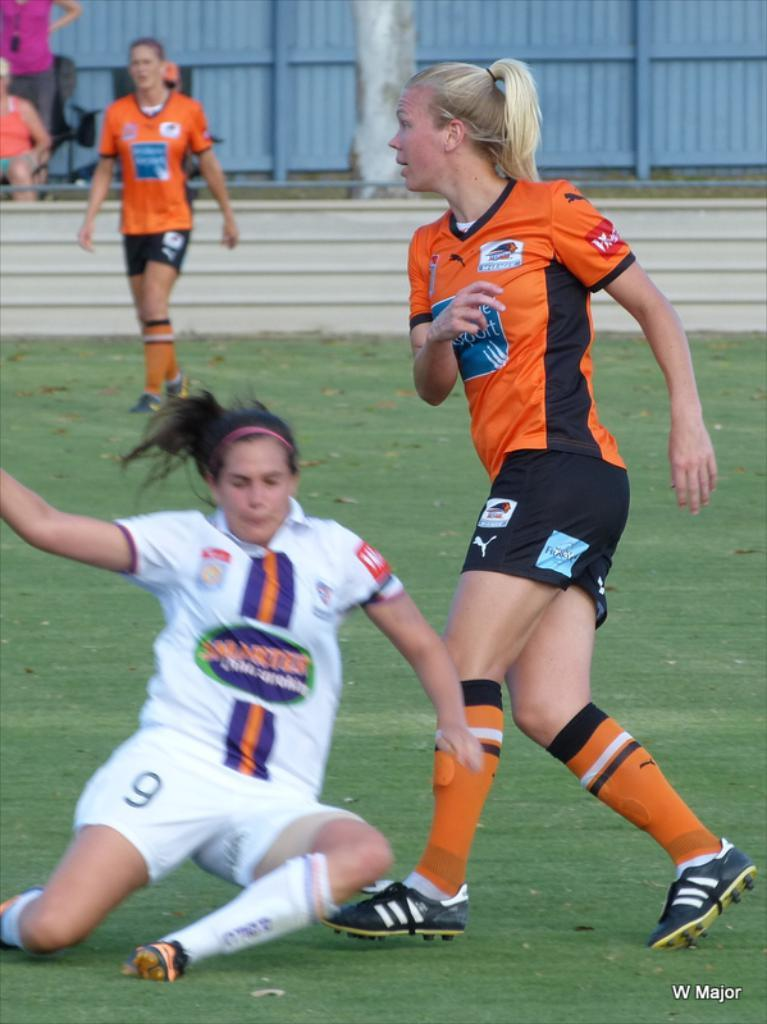<image>
Describe the image concisely. Player number 9 slips on the grass and starts to fall. 